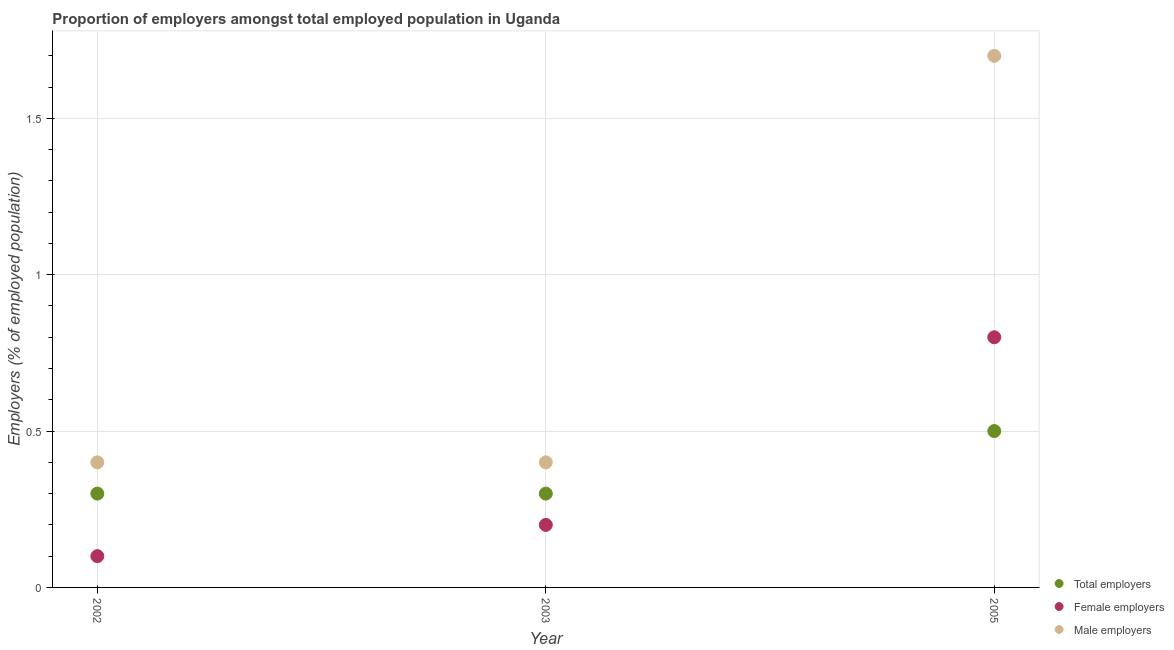How many different coloured dotlines are there?
Your answer should be compact. 3. Is the number of dotlines equal to the number of legend labels?
Provide a succinct answer. Yes. What is the percentage of male employers in 2002?
Ensure brevity in your answer.  0.4. Across all years, what is the maximum percentage of male employers?
Provide a short and direct response. 1.7. Across all years, what is the minimum percentage of female employers?
Give a very brief answer. 0.1. In which year was the percentage of total employers maximum?
Give a very brief answer. 2005. What is the total percentage of total employers in the graph?
Provide a short and direct response. 1.1. What is the difference between the percentage of total employers in 2002 and that in 2003?
Provide a succinct answer. 0. What is the difference between the percentage of male employers in 2003 and the percentage of total employers in 2002?
Your answer should be compact. 0.1. What is the average percentage of total employers per year?
Make the answer very short. 0.37. In the year 2002, what is the difference between the percentage of male employers and percentage of total employers?
Give a very brief answer. 0.1. In how many years, is the percentage of total employers greater than 1.4 %?
Provide a succinct answer. 0. Is the difference between the percentage of female employers in 2002 and 2005 greater than the difference between the percentage of total employers in 2002 and 2005?
Offer a very short reply. No. What is the difference between the highest and the second highest percentage of female employers?
Provide a short and direct response. 0.6. What is the difference between the highest and the lowest percentage of male employers?
Your response must be concise. 1.3. Is the sum of the percentage of total employers in 2003 and 2005 greater than the maximum percentage of male employers across all years?
Ensure brevity in your answer.  No. Is it the case that in every year, the sum of the percentage of total employers and percentage of female employers is greater than the percentage of male employers?
Provide a short and direct response. No. Is the percentage of total employers strictly greater than the percentage of female employers over the years?
Offer a terse response. No. How many years are there in the graph?
Offer a terse response. 3. Where does the legend appear in the graph?
Your answer should be very brief. Bottom right. How many legend labels are there?
Your answer should be compact. 3. What is the title of the graph?
Give a very brief answer. Proportion of employers amongst total employed population in Uganda. What is the label or title of the X-axis?
Your response must be concise. Year. What is the label or title of the Y-axis?
Provide a succinct answer. Employers (% of employed population). What is the Employers (% of employed population) in Total employers in 2002?
Ensure brevity in your answer.  0.3. What is the Employers (% of employed population) in Female employers in 2002?
Provide a succinct answer. 0.1. What is the Employers (% of employed population) of Male employers in 2002?
Provide a short and direct response. 0.4. What is the Employers (% of employed population) in Total employers in 2003?
Give a very brief answer. 0.3. What is the Employers (% of employed population) of Female employers in 2003?
Your answer should be very brief. 0.2. What is the Employers (% of employed population) of Male employers in 2003?
Make the answer very short. 0.4. What is the Employers (% of employed population) of Total employers in 2005?
Keep it short and to the point. 0.5. What is the Employers (% of employed population) of Female employers in 2005?
Offer a terse response. 0.8. What is the Employers (% of employed population) of Male employers in 2005?
Keep it short and to the point. 1.7. Across all years, what is the maximum Employers (% of employed population) of Total employers?
Provide a succinct answer. 0.5. Across all years, what is the maximum Employers (% of employed population) of Female employers?
Provide a short and direct response. 0.8. Across all years, what is the maximum Employers (% of employed population) in Male employers?
Provide a short and direct response. 1.7. Across all years, what is the minimum Employers (% of employed population) in Total employers?
Provide a short and direct response. 0.3. Across all years, what is the minimum Employers (% of employed population) in Female employers?
Ensure brevity in your answer.  0.1. Across all years, what is the minimum Employers (% of employed population) of Male employers?
Provide a short and direct response. 0.4. What is the total Employers (% of employed population) of Total employers in the graph?
Offer a terse response. 1.1. What is the total Employers (% of employed population) of Female employers in the graph?
Provide a short and direct response. 1.1. What is the total Employers (% of employed population) in Male employers in the graph?
Your answer should be very brief. 2.5. What is the difference between the Employers (% of employed population) of Total employers in 2002 and that in 2003?
Offer a very short reply. 0. What is the difference between the Employers (% of employed population) in Female employers in 2002 and that in 2003?
Make the answer very short. -0.1. What is the difference between the Employers (% of employed population) of Total employers in 2002 and that in 2005?
Offer a very short reply. -0.2. What is the difference between the Employers (% of employed population) in Female employers in 2002 and that in 2005?
Your answer should be compact. -0.7. What is the difference between the Employers (% of employed population) of Total employers in 2003 and that in 2005?
Provide a succinct answer. -0.2. What is the difference between the Employers (% of employed population) of Female employers in 2003 and that in 2005?
Your response must be concise. -0.6. What is the difference between the Employers (% of employed population) of Total employers in 2002 and the Employers (% of employed population) of Female employers in 2003?
Offer a terse response. 0.1. What is the difference between the Employers (% of employed population) in Female employers in 2002 and the Employers (% of employed population) in Male employers in 2003?
Provide a succinct answer. -0.3. What is the difference between the Employers (% of employed population) of Total employers in 2002 and the Employers (% of employed population) of Female employers in 2005?
Make the answer very short. -0.5. What is the difference between the Employers (% of employed population) of Total employers in 2002 and the Employers (% of employed population) of Male employers in 2005?
Give a very brief answer. -1.4. What is the difference between the Employers (% of employed population) of Female employers in 2002 and the Employers (% of employed population) of Male employers in 2005?
Make the answer very short. -1.6. What is the difference between the Employers (% of employed population) in Total employers in 2003 and the Employers (% of employed population) in Male employers in 2005?
Ensure brevity in your answer.  -1.4. What is the difference between the Employers (% of employed population) of Female employers in 2003 and the Employers (% of employed population) of Male employers in 2005?
Give a very brief answer. -1.5. What is the average Employers (% of employed population) of Total employers per year?
Keep it short and to the point. 0.37. What is the average Employers (% of employed population) of Female employers per year?
Provide a succinct answer. 0.37. In the year 2002, what is the difference between the Employers (% of employed population) in Total employers and Employers (% of employed population) in Female employers?
Keep it short and to the point. 0.2. In the year 2002, what is the difference between the Employers (% of employed population) of Total employers and Employers (% of employed population) of Male employers?
Provide a succinct answer. -0.1. In the year 2002, what is the difference between the Employers (% of employed population) in Female employers and Employers (% of employed population) in Male employers?
Your response must be concise. -0.3. In the year 2003, what is the difference between the Employers (% of employed population) of Total employers and Employers (% of employed population) of Female employers?
Give a very brief answer. 0.1. In the year 2003, what is the difference between the Employers (% of employed population) in Total employers and Employers (% of employed population) in Male employers?
Your answer should be compact. -0.1. In the year 2003, what is the difference between the Employers (% of employed population) in Female employers and Employers (% of employed population) in Male employers?
Your response must be concise. -0.2. In the year 2005, what is the difference between the Employers (% of employed population) of Total employers and Employers (% of employed population) of Female employers?
Provide a succinct answer. -0.3. What is the ratio of the Employers (% of employed population) of Total employers in 2002 to that in 2003?
Offer a terse response. 1. What is the ratio of the Employers (% of employed population) in Female employers in 2002 to that in 2003?
Give a very brief answer. 0.5. What is the ratio of the Employers (% of employed population) in Female employers in 2002 to that in 2005?
Provide a succinct answer. 0.12. What is the ratio of the Employers (% of employed population) of Male employers in 2002 to that in 2005?
Provide a succinct answer. 0.24. What is the ratio of the Employers (% of employed population) in Total employers in 2003 to that in 2005?
Your answer should be compact. 0.6. What is the ratio of the Employers (% of employed population) of Male employers in 2003 to that in 2005?
Provide a short and direct response. 0.24. What is the difference between the highest and the second highest Employers (% of employed population) in Total employers?
Your answer should be very brief. 0.2. What is the difference between the highest and the second highest Employers (% of employed population) of Female employers?
Your answer should be compact. 0.6. What is the difference between the highest and the lowest Employers (% of employed population) in Female employers?
Keep it short and to the point. 0.7. What is the difference between the highest and the lowest Employers (% of employed population) of Male employers?
Your answer should be very brief. 1.3. 